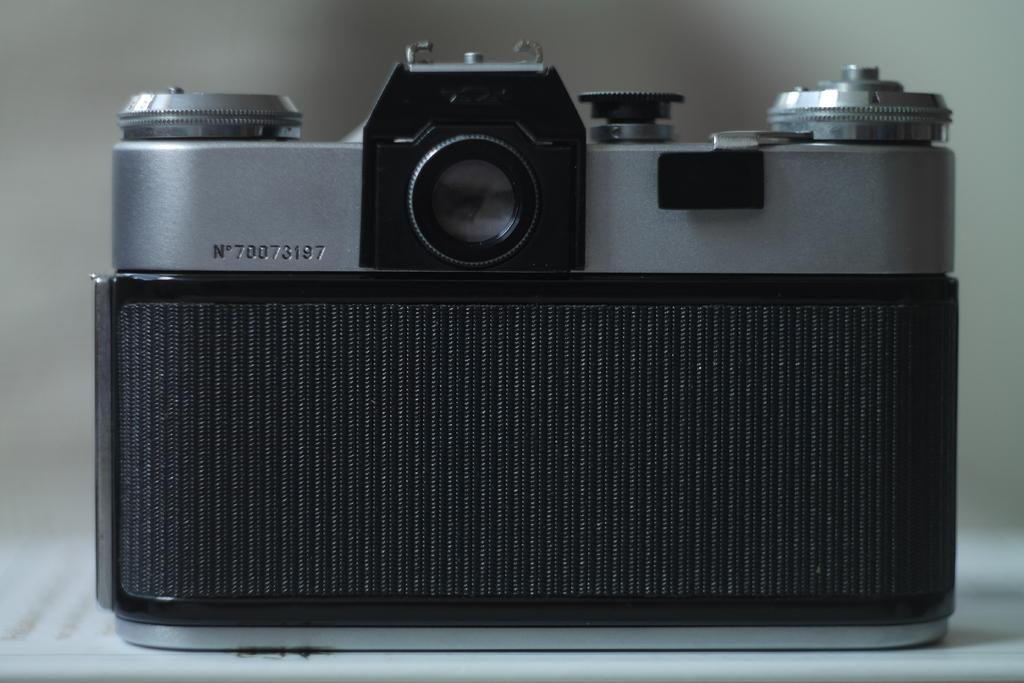What is the main subject in the center of the image? There is a camera in the center of the image. What can be seen in the background of the image? There is a curtain in the background of the image. Is there any furniture visible at the bottom of the image? It is mentioned that there might be a table at the bottom of the image. How many toes can be seen on the cow in the image? There is no cow present in the image, so it is not possible to determine the number of toes. 